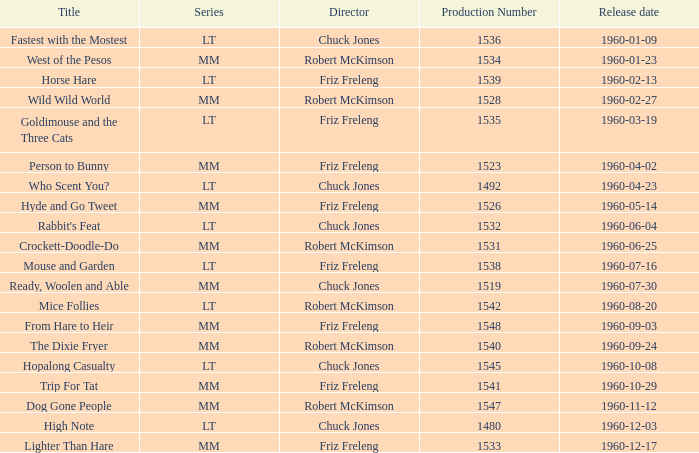What is the manufacturing figure for the episode directed by robert mckimson titled mice follies? 1.0. 